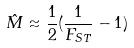<formula> <loc_0><loc_0><loc_500><loc_500>\hat { M } \approx \frac { 1 } { 2 } ( \frac { 1 } { F _ { S T } } - 1 )</formula> 